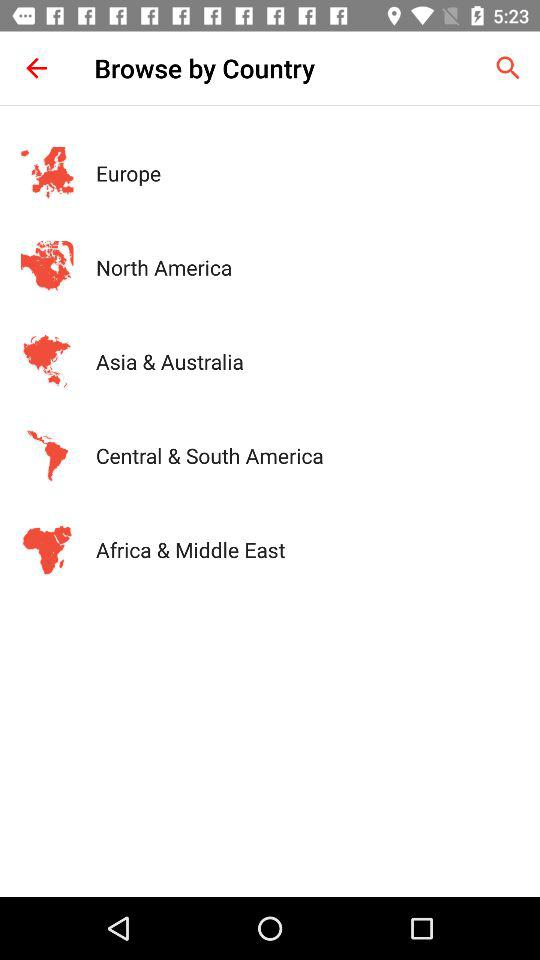How many regions are there?
Answer the question using a single word or phrase. 5 